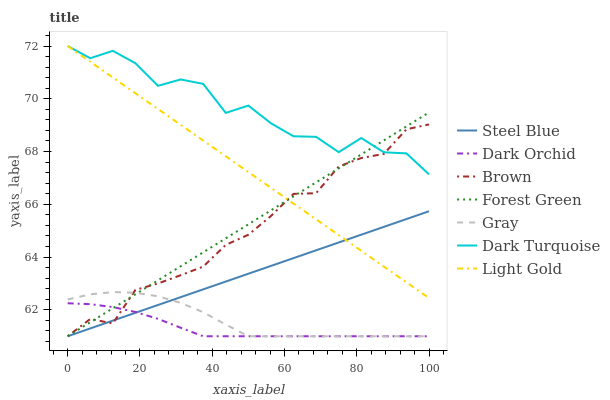Does Dark Orchid have the minimum area under the curve?
Answer yes or no. Yes. Does Dark Turquoise have the maximum area under the curve?
Answer yes or no. Yes. Does Gray have the minimum area under the curve?
Answer yes or no. No. Does Gray have the maximum area under the curve?
Answer yes or no. No. Is Light Gold the smoothest?
Answer yes or no. Yes. Is Dark Turquoise the roughest?
Answer yes or no. Yes. Is Gray the smoothest?
Answer yes or no. No. Is Gray the roughest?
Answer yes or no. No. Does Brown have the lowest value?
Answer yes or no. Yes. Does Dark Turquoise have the lowest value?
Answer yes or no. No. Does Light Gold have the highest value?
Answer yes or no. Yes. Does Gray have the highest value?
Answer yes or no. No. Is Gray less than Light Gold?
Answer yes or no. Yes. Is Light Gold greater than Dark Orchid?
Answer yes or no. Yes. Does Light Gold intersect Dark Turquoise?
Answer yes or no. Yes. Is Light Gold less than Dark Turquoise?
Answer yes or no. No. Is Light Gold greater than Dark Turquoise?
Answer yes or no. No. Does Gray intersect Light Gold?
Answer yes or no. No. 